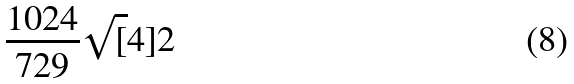<formula> <loc_0><loc_0><loc_500><loc_500>\frac { 1 0 2 4 } { 7 2 9 } \sqrt { [ } 4 ] { 2 }</formula> 